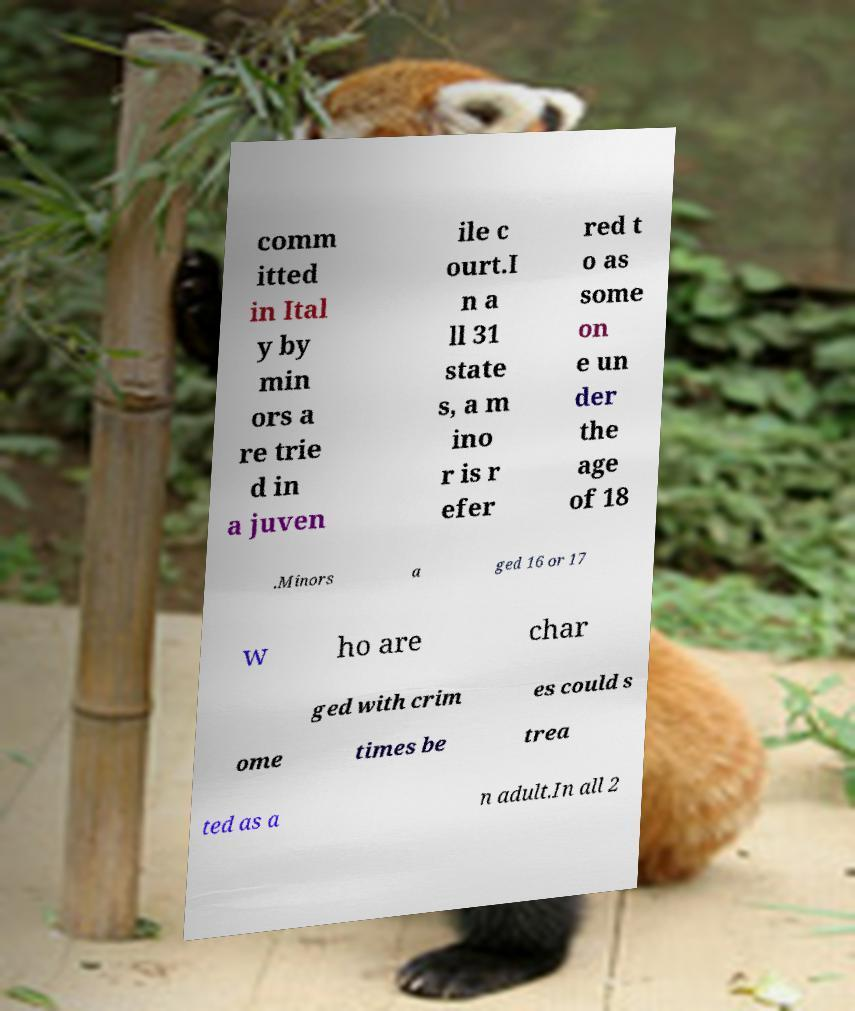Please identify and transcribe the text found in this image. comm itted in Ital y by min ors a re trie d in a juven ile c ourt.I n a ll 31 state s, a m ino r is r efer red t o as some on e un der the age of 18 .Minors a ged 16 or 17 w ho are char ged with crim es could s ome times be trea ted as a n adult.In all 2 